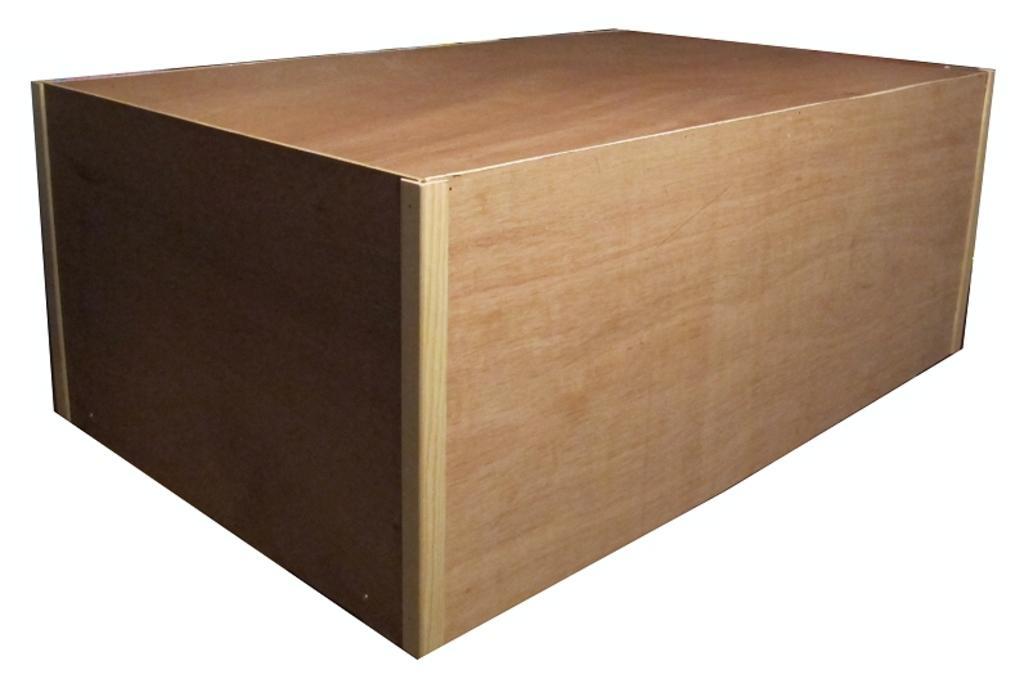Can you describe this image briefly? In this picture i can see a wooden box. The background is white in color. 